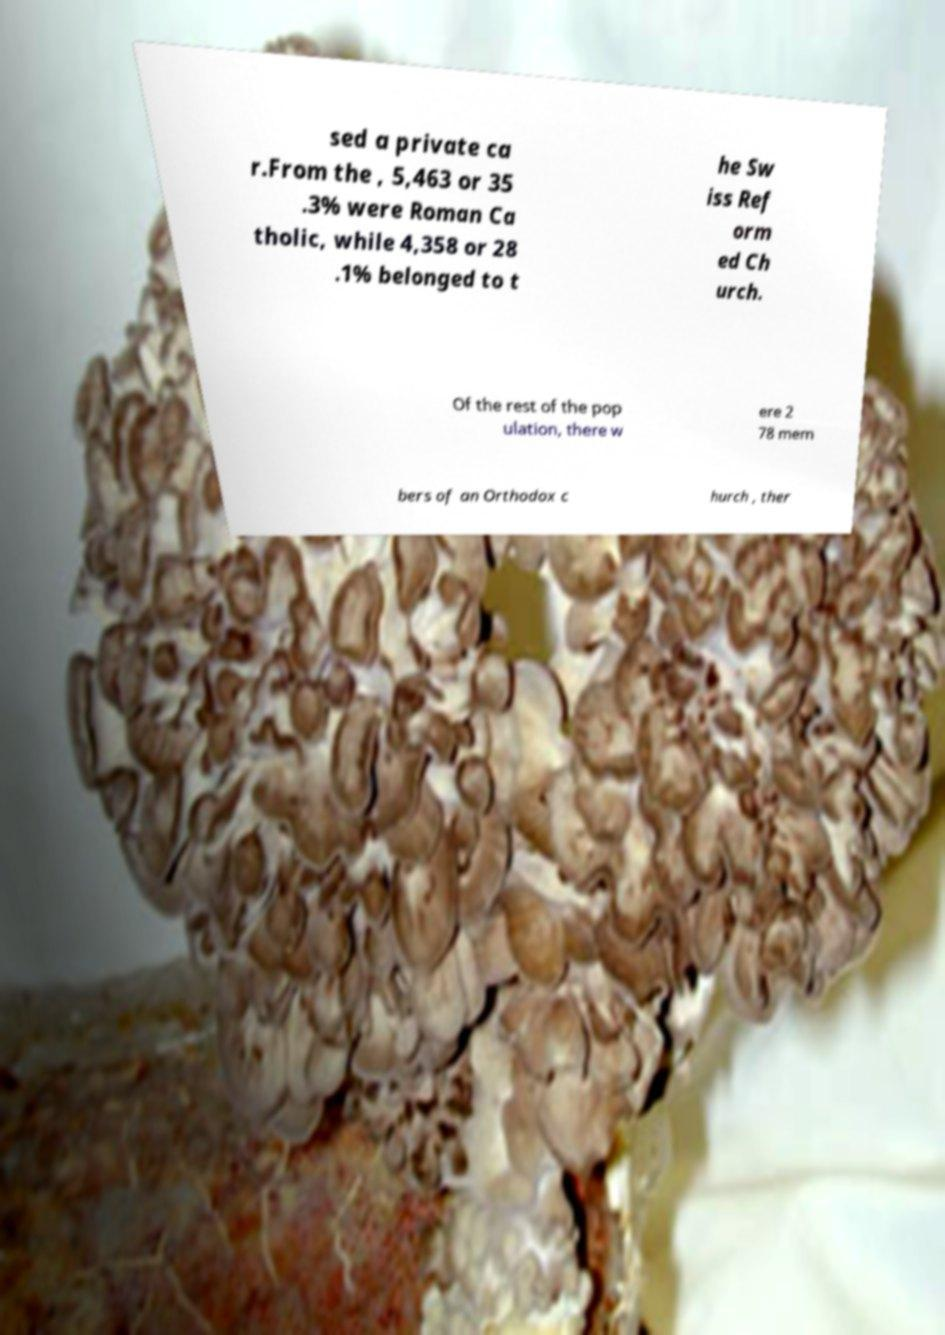Please read and relay the text visible in this image. What does it say? sed a private ca r.From the , 5,463 or 35 .3% were Roman Ca tholic, while 4,358 or 28 .1% belonged to t he Sw iss Ref orm ed Ch urch. Of the rest of the pop ulation, there w ere 2 78 mem bers of an Orthodox c hurch , ther 